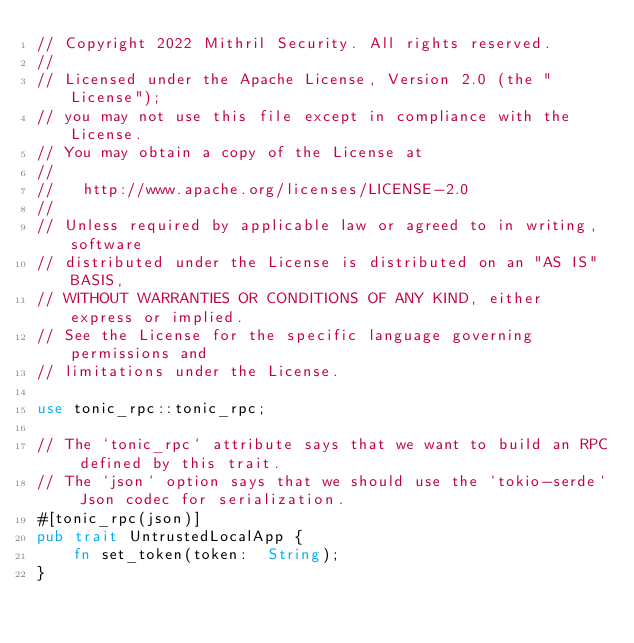<code> <loc_0><loc_0><loc_500><loc_500><_Rust_>// Copyright 2022 Mithril Security. All rights reserved.
//
// Licensed under the Apache License, Version 2.0 (the "License");
// you may not use this file except in compliance with the License.
// You may obtain a copy of the License at
//
//   http://www.apache.org/licenses/LICENSE-2.0
//
// Unless required by applicable law or agreed to in writing, software
// distributed under the License is distributed on an "AS IS" BASIS,
// WITHOUT WARRANTIES OR CONDITIONS OF ANY KIND, either express or implied.
// See the License for the specific language governing permissions and
// limitations under the License.

use tonic_rpc::tonic_rpc;

// The `tonic_rpc` attribute says that we want to build an RPC defined by this trait.
// The `json` option says that we should use the `tokio-serde` Json codec for serialization.
#[tonic_rpc(json)]
pub trait UntrustedLocalApp {
    fn set_token(token:  String);
}
</code> 